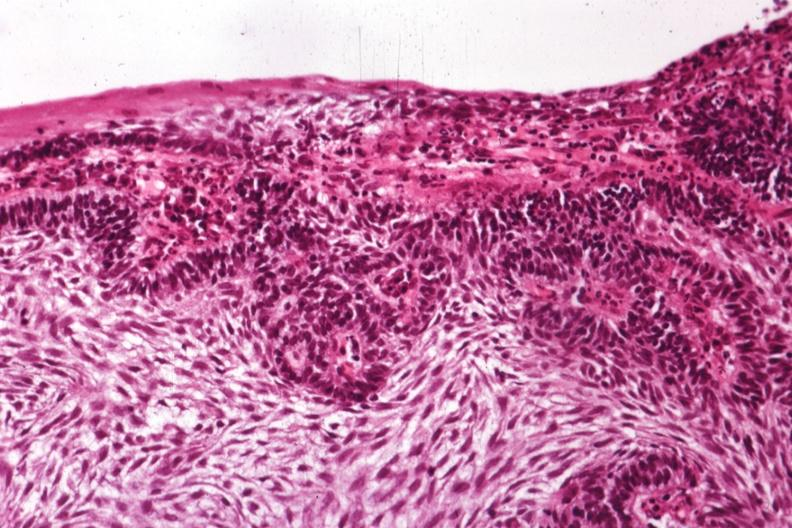s bone, mandible present?
Answer the question using a single word or phrase. Yes 